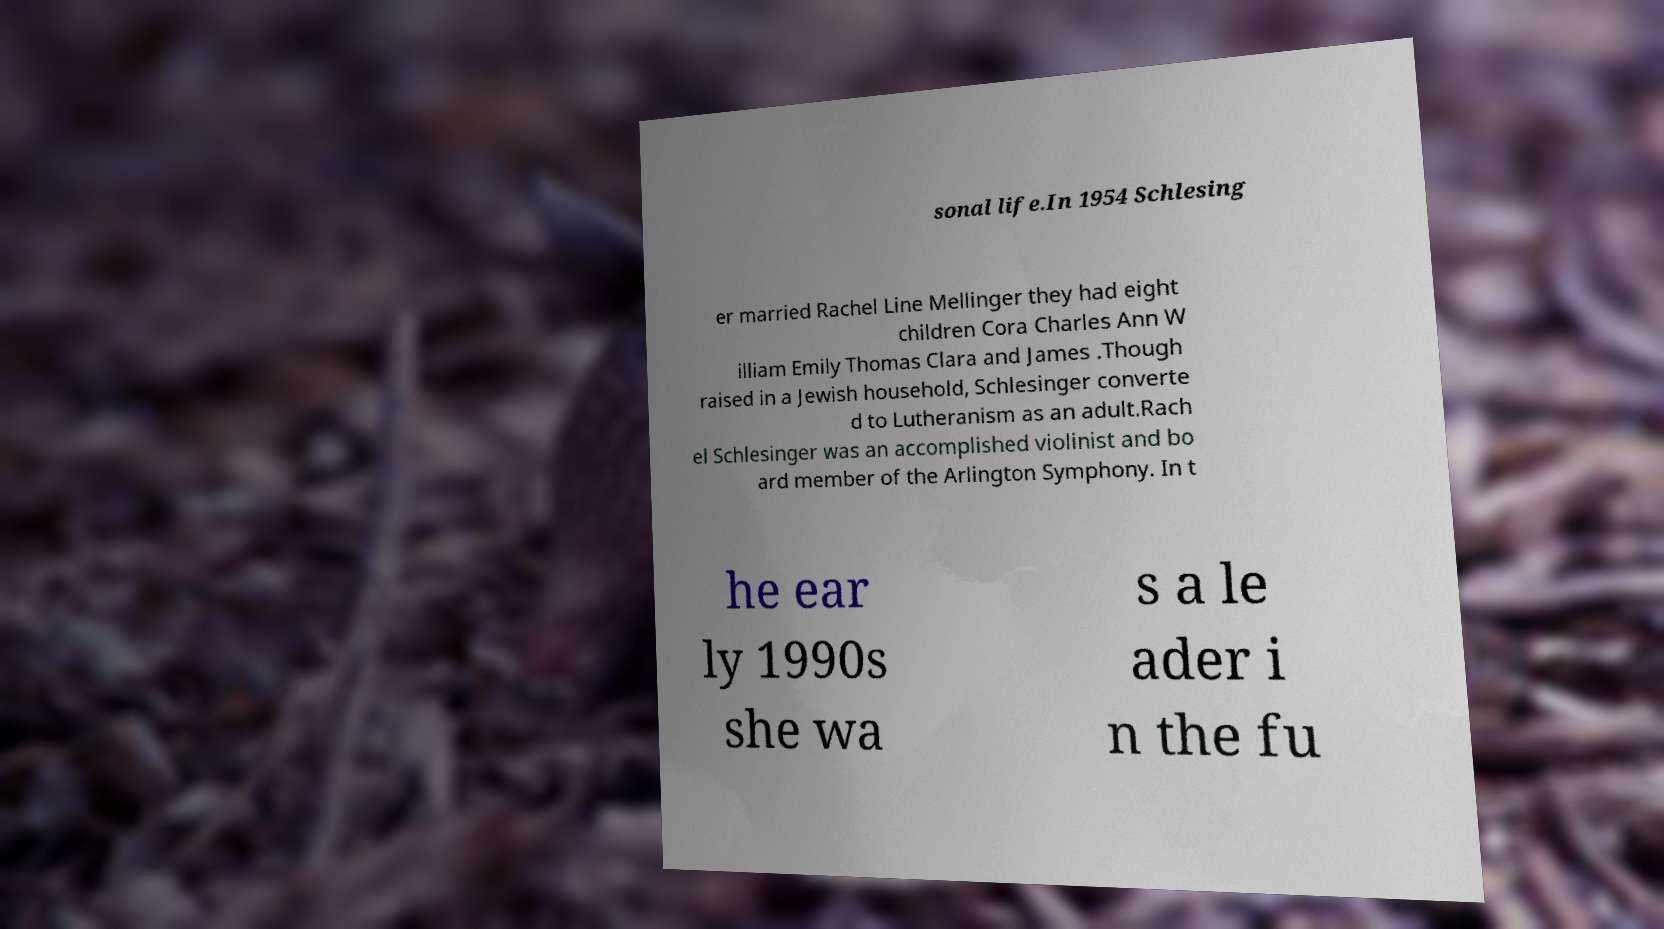For documentation purposes, I need the text within this image transcribed. Could you provide that? sonal life.In 1954 Schlesing er married Rachel Line Mellinger they had eight children Cora Charles Ann W illiam Emily Thomas Clara and James .Though raised in a Jewish household, Schlesinger converte d to Lutheranism as an adult.Rach el Schlesinger was an accomplished violinist and bo ard member of the Arlington Symphony. In t he ear ly 1990s she wa s a le ader i n the fu 